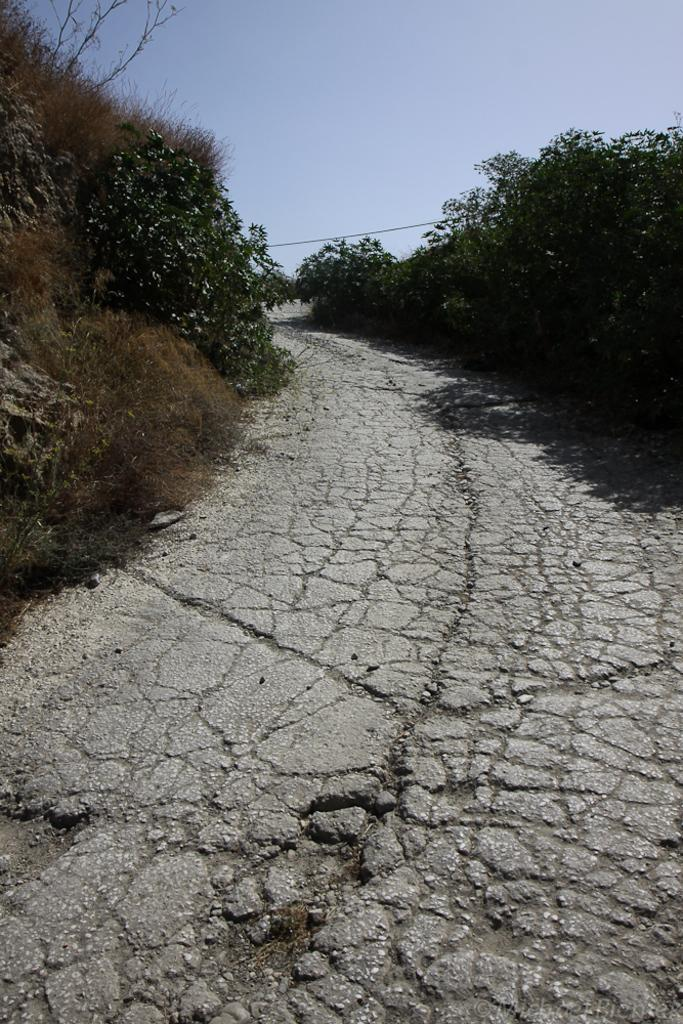What is the main feature of the image? There is a pathway in the image. What type of vegetation can be seen in the image? There are trees in the image, and they are green in color. What is the color of the sky in the image? The sky is visible in the image, and it is blue in color. Can you see any bones in the image? There are no bones present in the image. What type of lace is draped over the trees in the image? There is no lace present in the image; it features trees with green leaves. 